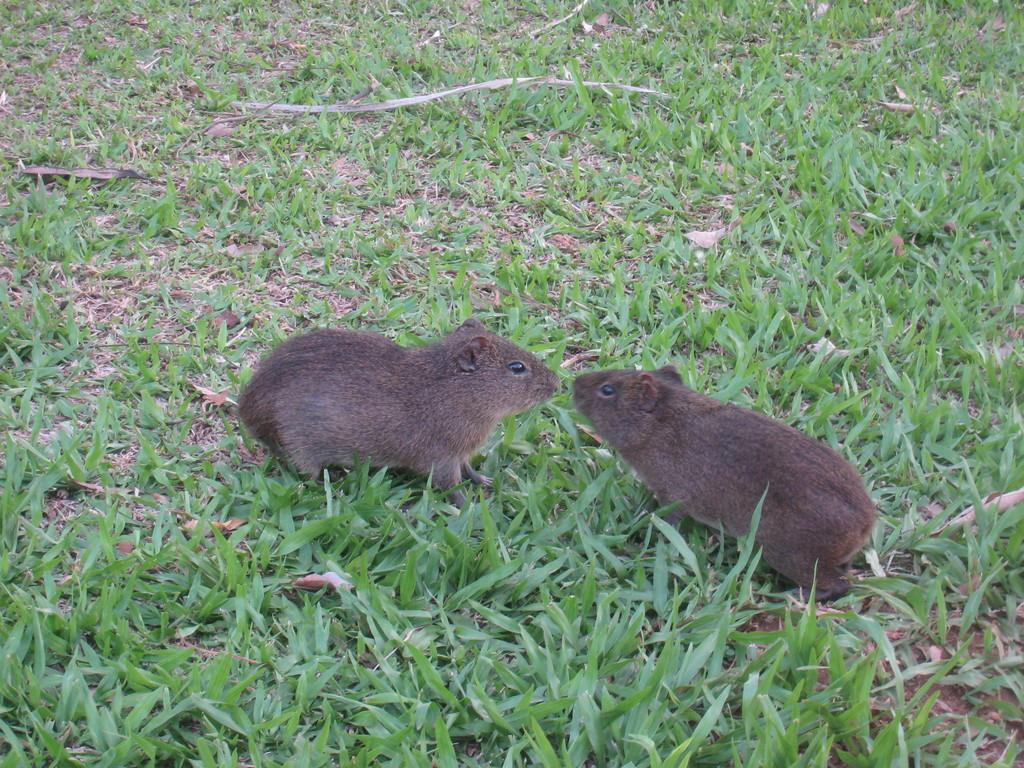Can you describe this image briefly? In this image we can see two rats on the grass and also we can see dry leaves here. 